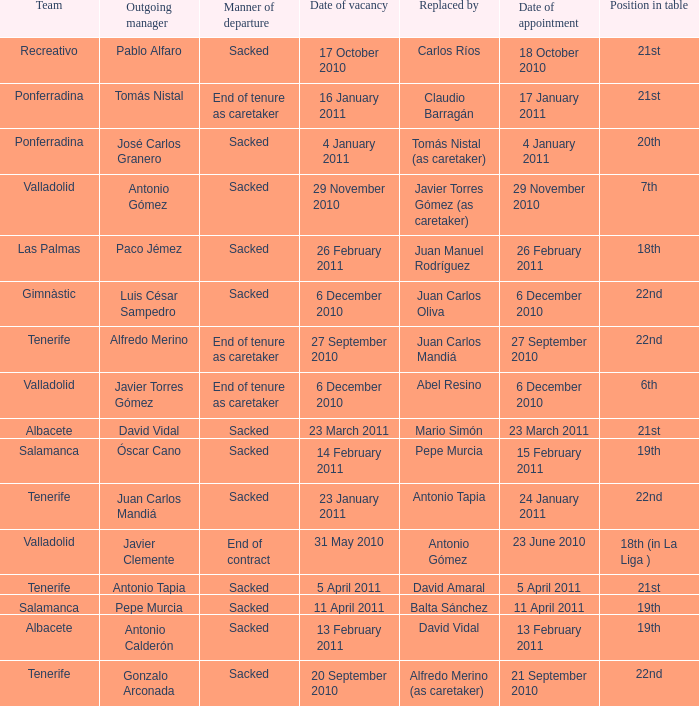How many teams had an appointment date of 11 april 2011 1.0. 